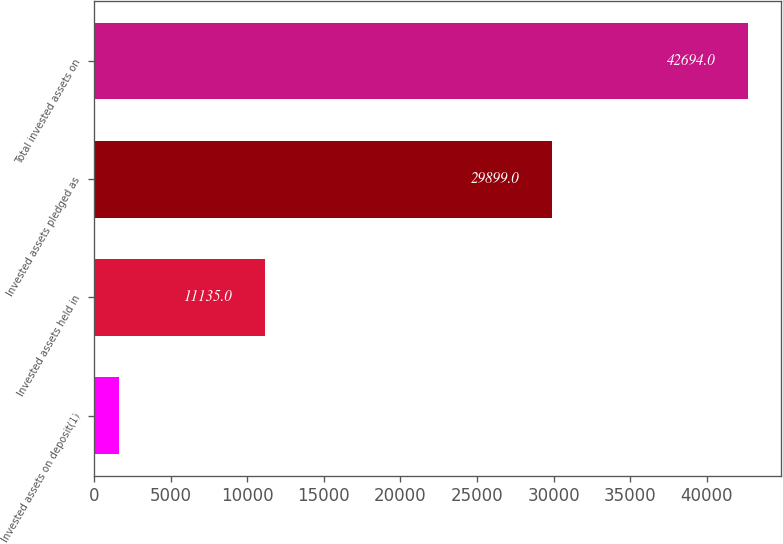Convert chart to OTSL. <chart><loc_0><loc_0><loc_500><loc_500><bar_chart><fcel>Invested assets on deposit(1)<fcel>Invested assets held in<fcel>Invested assets pledged as<fcel>Total invested assets on<nl><fcel>1660<fcel>11135<fcel>29899<fcel>42694<nl></chart> 